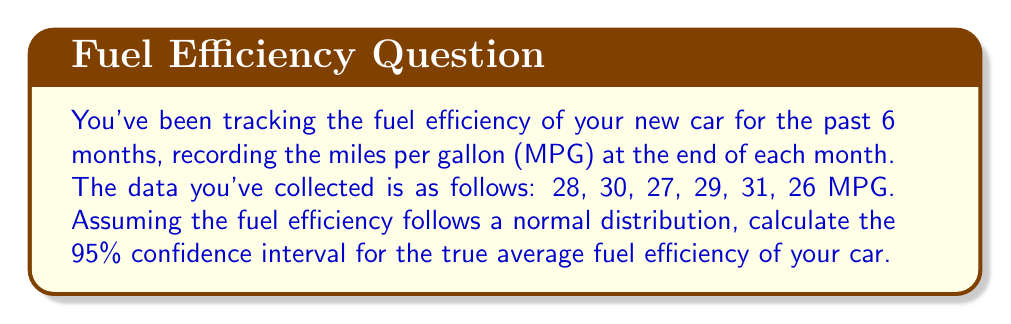Can you solve this math problem? To calculate the 95% confidence interval, we'll follow these steps:

1. Calculate the sample mean ($\bar{x}$):
   $$\bar{x} = \frac{28 + 30 + 27 + 29 + 31 + 26}{6} = 28.5 \text{ MPG}$$

2. Calculate the sample standard deviation ($s$):
   $$s = \sqrt{\frac{\sum_{i=1}^{n} (x_i - \bar{x})^2}{n - 1}}$$
   $$s = \sqrt{\frac{(28-28.5)^2 + (30-28.5)^2 + (27-28.5)^2 + (29-28.5)^2 + (31-28.5)^2 + (26-28.5)^2}{6 - 1}}$$
   $$s = \sqrt{\frac{0.25 + 2.25 + 2.25 + 0.25 + 6.25 + 6.25}{5}} = \sqrt{\frac{17.5}{5}} = 1.87 \text{ MPG}$$

3. Determine the t-value for a 95% confidence interval with 5 degrees of freedom (n-1):
   $t_{0.025, 5} = 2.571$ (from t-distribution table)

4. Calculate the margin of error:
   $$\text{Margin of Error} = t_{0.025, 5} \cdot \frac{s}{\sqrt{n}} = 2.571 \cdot \frac{1.87}{\sqrt{6}} = 1.96 \text{ MPG}$$

5. Compute the confidence interval:
   $$\text{CI} = \bar{x} \pm \text{Margin of Error}$$
   $$\text{CI} = 28.5 \pm 1.96 \text{ MPG}$$
   $$\text{CI} = (26.54, 30.46) \text{ MPG}$$
Answer: (26.54, 30.46) MPG 